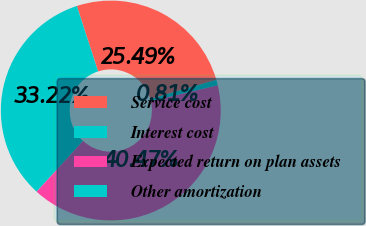<chart> <loc_0><loc_0><loc_500><loc_500><pie_chart><fcel>Service cost<fcel>Interest cost<fcel>Expected return on plan assets<fcel>Other amortization<nl><fcel>25.49%<fcel>33.22%<fcel>40.47%<fcel>0.81%<nl></chart> 